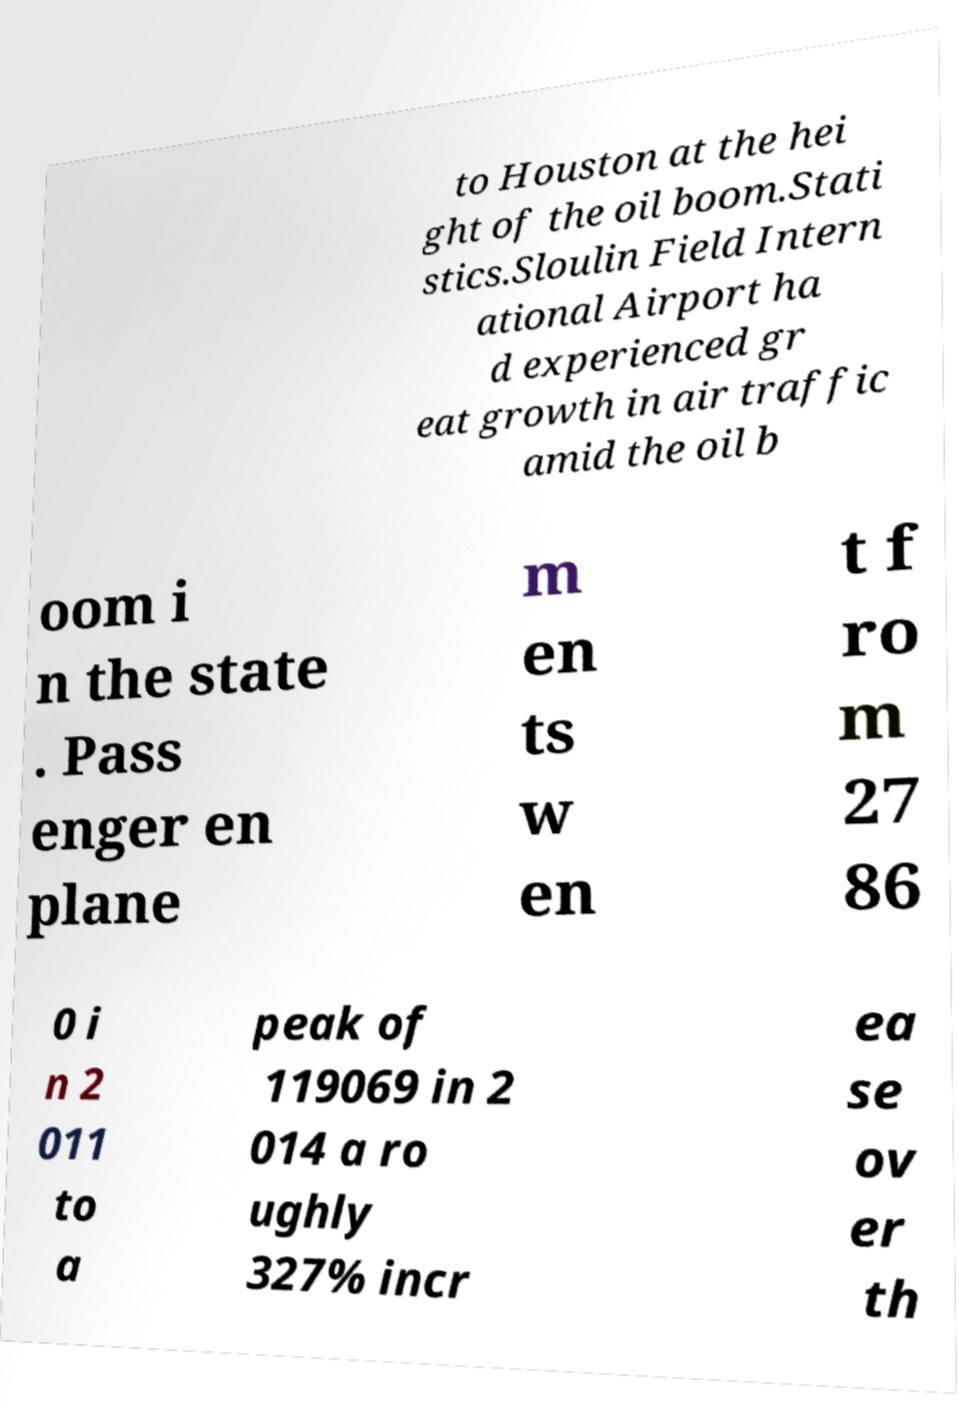Could you extract and type out the text from this image? to Houston at the hei ght of the oil boom.Stati stics.Sloulin Field Intern ational Airport ha d experienced gr eat growth in air traffic amid the oil b oom i n the state . Pass enger en plane m en ts w en t f ro m 27 86 0 i n 2 011 to a peak of 119069 in 2 014 a ro ughly 327% incr ea se ov er th 